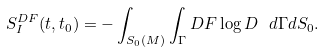Convert formula to latex. <formula><loc_0><loc_0><loc_500><loc_500>S _ { I } ^ { D F } ( t , t _ { 0 } ) = - \int _ { S _ { 0 } ( M ) } \int _ { \Gamma } D F \log D \ d \Gamma d S _ { 0 } .</formula> 